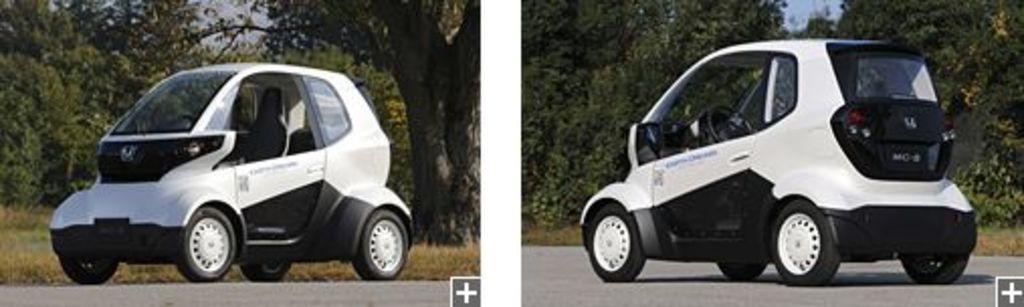In one or two sentences, can you explain what this image depicts? In this picture I can see collage of two pictures in the the first picture I can see a car and trees in the back and in the second picture I can see a car in another direction and I can see trees in the back and the car is white and black in color. 